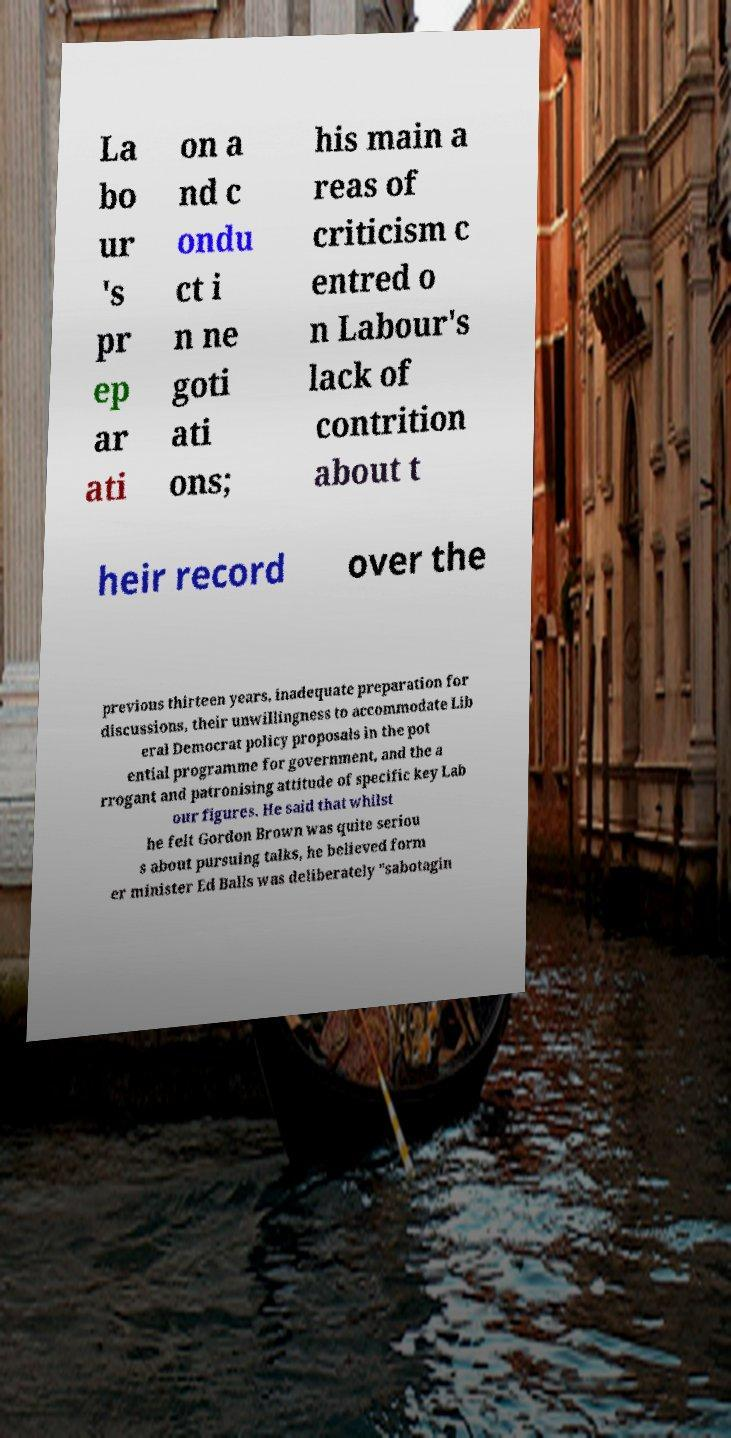Can you accurately transcribe the text from the provided image for me? La bo ur 's pr ep ar ati on a nd c ondu ct i n ne goti ati ons; his main a reas of criticism c entred o n Labour's lack of contrition about t heir record over the previous thirteen years, inadequate preparation for discussions, their unwillingness to accommodate Lib eral Democrat policy proposals in the pot ential programme for government, and the a rrogant and patronising attitude of specific key Lab our figures. He said that whilst he felt Gordon Brown was quite seriou s about pursuing talks, he believed form er minister Ed Balls was deliberately "sabotagin 